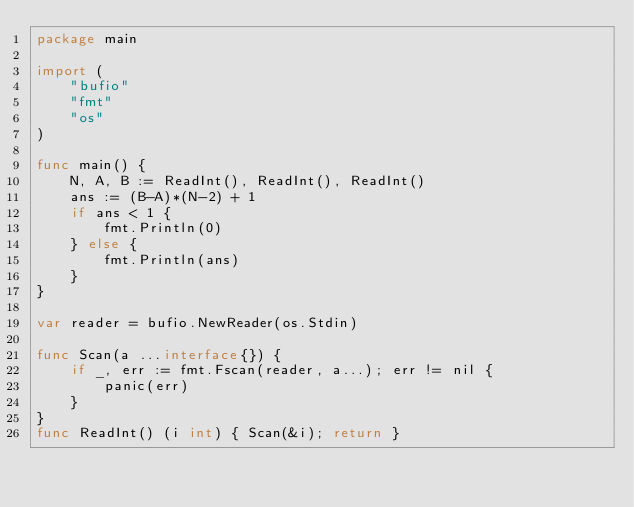Convert code to text. <code><loc_0><loc_0><loc_500><loc_500><_Go_>package main

import (
	"bufio"
	"fmt"
	"os"
)

func main() {
	N, A, B := ReadInt(), ReadInt(), ReadInt()
	ans := (B-A)*(N-2) + 1
	if ans < 1 {
		fmt.Println(0)
	} else {
		fmt.Println(ans)
	}
}

var reader = bufio.NewReader(os.Stdin)

func Scan(a ...interface{}) {
	if _, err := fmt.Fscan(reader, a...); err != nil {
		panic(err)
	}
}
func ReadInt() (i int) { Scan(&i); return }
</code> 